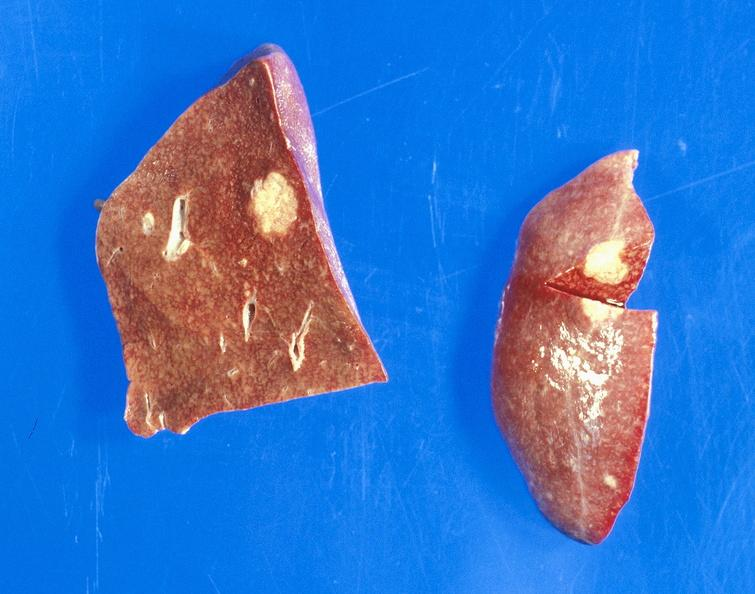does this image shows of smooth muscle cell with lipid in sarcoplasm and lipid show bronchiogenic carcinoma, smoker, metastases?
Answer the question using a single word or phrase. No 